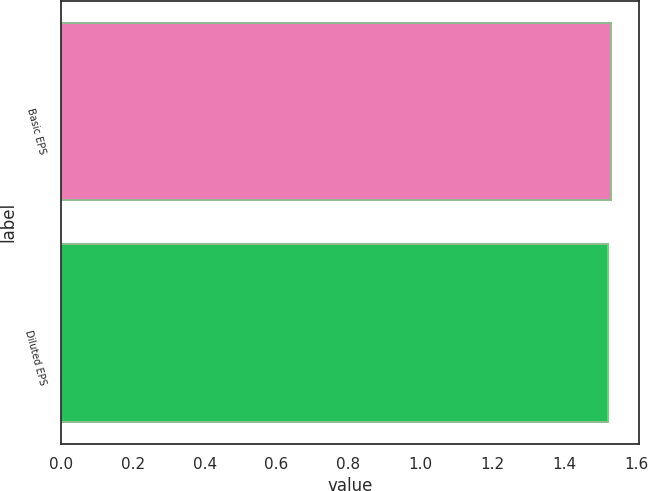Convert chart. <chart><loc_0><loc_0><loc_500><loc_500><bar_chart><fcel>Basic EPS<fcel>Diluted EPS<nl><fcel>1.53<fcel>1.52<nl></chart> 